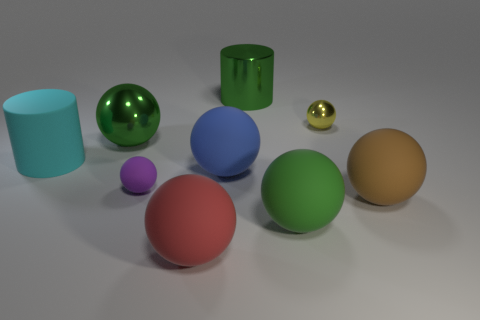What is the material of the large blue object that is the same shape as the small yellow metal object?
Your answer should be very brief. Rubber. There is a shiny cylinder that is the same size as the red object; what color is it?
Offer a very short reply. Green. Are there the same number of big brown rubber balls that are to the left of the yellow thing and brown spheres?
Offer a very short reply. No. There is a tiny sphere that is behind the large green sphere behind the big brown rubber object; what is its color?
Offer a very short reply. Yellow. What size is the green ball on the left side of the green object right of the green cylinder?
Keep it short and to the point. Large. There is another sphere that is the same color as the big metal sphere; what is its size?
Your answer should be very brief. Large. What number of other things are there of the same size as the green metal cylinder?
Offer a very short reply. 6. There is a big rubber ball that is behind the rubber sphere right of the tiny yellow object right of the green rubber ball; what is its color?
Offer a very short reply. Blue. How many other things are there of the same shape as the large red thing?
Provide a succinct answer. 6. There is a green object that is in front of the purple rubber object; what is its shape?
Offer a terse response. Sphere. 